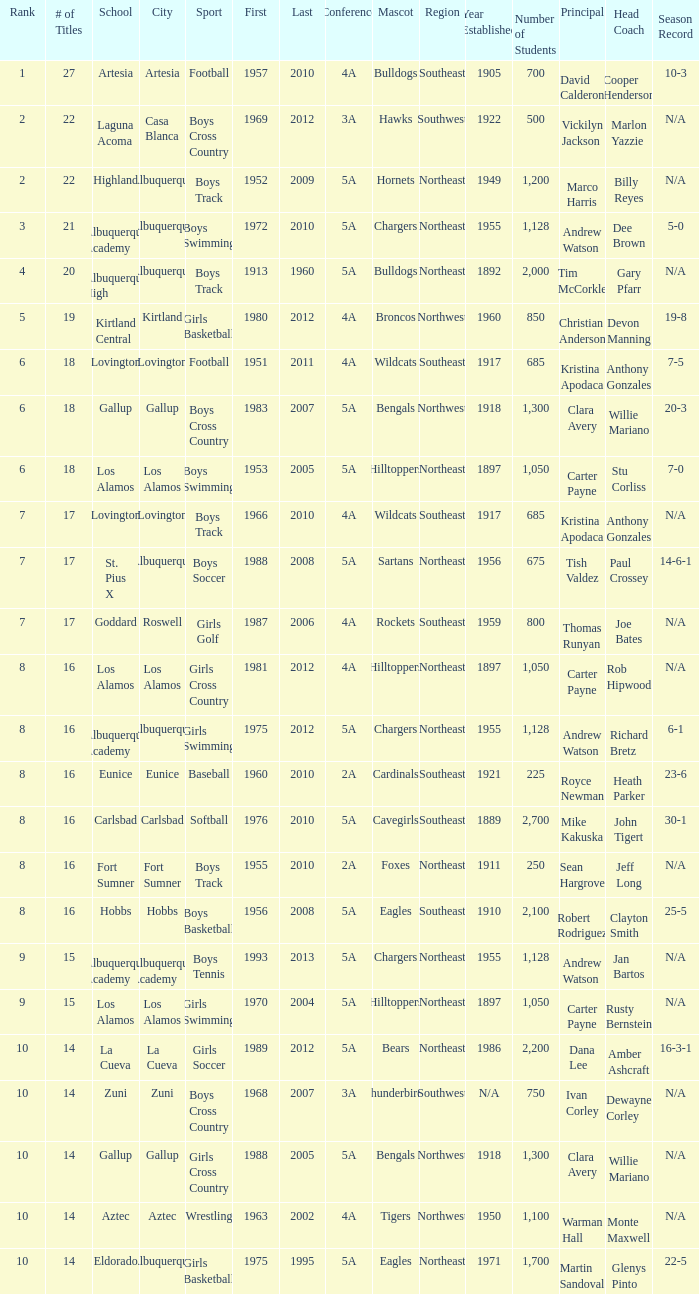What is the highest rank for the boys swimming team in Albuquerque? 3.0. 